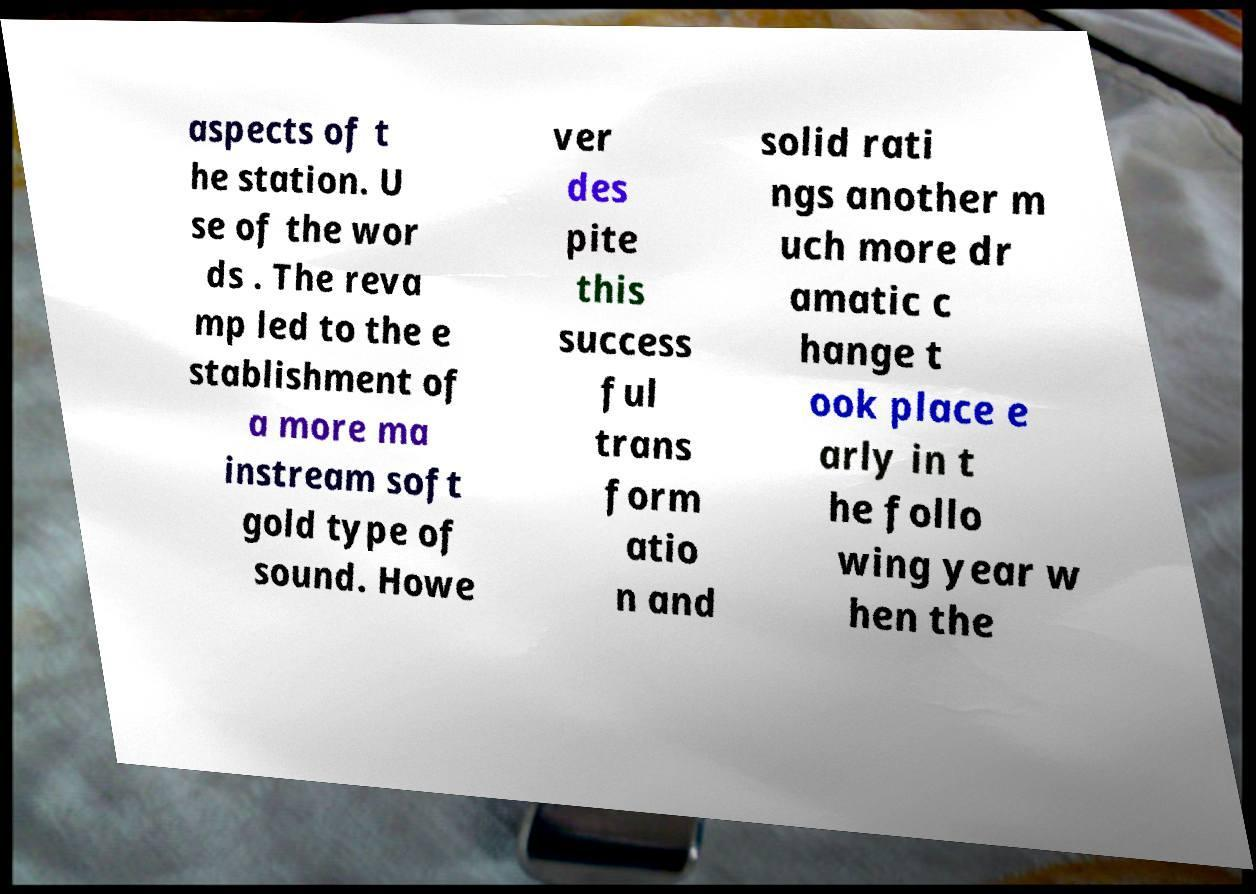Could you extract and type out the text from this image? aspects of t he station. U se of the wor ds . The reva mp led to the e stablishment of a more ma instream soft gold type of sound. Howe ver des pite this success ful trans form atio n and solid rati ngs another m uch more dr amatic c hange t ook place e arly in t he follo wing year w hen the 